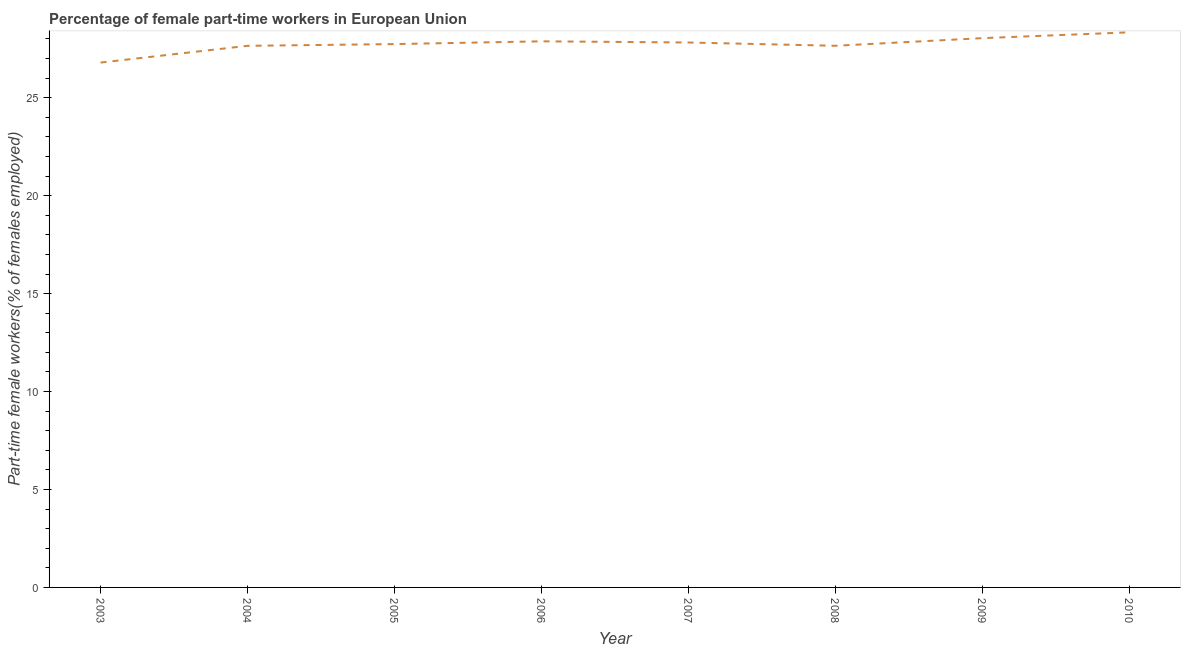What is the percentage of part-time female workers in 2006?
Make the answer very short. 27.88. Across all years, what is the maximum percentage of part-time female workers?
Give a very brief answer. 28.34. Across all years, what is the minimum percentage of part-time female workers?
Make the answer very short. 26.8. In which year was the percentage of part-time female workers minimum?
Give a very brief answer. 2003. What is the sum of the percentage of part-time female workers?
Your response must be concise. 221.92. What is the difference between the percentage of part-time female workers in 2003 and 2006?
Your response must be concise. -1.08. What is the average percentage of part-time female workers per year?
Offer a very short reply. 27.74. What is the median percentage of part-time female workers?
Offer a very short reply. 27.78. Do a majority of the years between 2010 and 2004 (inclusive) have percentage of part-time female workers greater than 24 %?
Give a very brief answer. Yes. What is the ratio of the percentage of part-time female workers in 2004 to that in 2006?
Offer a very short reply. 0.99. Is the percentage of part-time female workers in 2005 less than that in 2007?
Keep it short and to the point. Yes. What is the difference between the highest and the second highest percentage of part-time female workers?
Offer a very short reply. 0.3. What is the difference between the highest and the lowest percentage of part-time female workers?
Offer a terse response. 1.54. What is the title of the graph?
Provide a succinct answer. Percentage of female part-time workers in European Union. What is the label or title of the Y-axis?
Provide a succinct answer. Part-time female workers(% of females employed). What is the Part-time female workers(% of females employed) of 2003?
Make the answer very short. 26.8. What is the Part-time female workers(% of females employed) in 2004?
Ensure brevity in your answer.  27.65. What is the Part-time female workers(% of females employed) in 2005?
Give a very brief answer. 27.74. What is the Part-time female workers(% of females employed) in 2006?
Make the answer very short. 27.88. What is the Part-time female workers(% of females employed) of 2007?
Provide a succinct answer. 27.82. What is the Part-time female workers(% of females employed) of 2008?
Keep it short and to the point. 27.65. What is the Part-time female workers(% of females employed) in 2009?
Provide a short and direct response. 28.04. What is the Part-time female workers(% of females employed) in 2010?
Your response must be concise. 28.34. What is the difference between the Part-time female workers(% of females employed) in 2003 and 2004?
Keep it short and to the point. -0.85. What is the difference between the Part-time female workers(% of females employed) in 2003 and 2005?
Ensure brevity in your answer.  -0.94. What is the difference between the Part-time female workers(% of females employed) in 2003 and 2006?
Your answer should be very brief. -1.08. What is the difference between the Part-time female workers(% of females employed) in 2003 and 2007?
Your response must be concise. -1.02. What is the difference between the Part-time female workers(% of females employed) in 2003 and 2008?
Ensure brevity in your answer.  -0.86. What is the difference between the Part-time female workers(% of females employed) in 2003 and 2009?
Provide a short and direct response. -1.25. What is the difference between the Part-time female workers(% of females employed) in 2003 and 2010?
Offer a very short reply. -1.54. What is the difference between the Part-time female workers(% of females employed) in 2004 and 2005?
Give a very brief answer. -0.09. What is the difference between the Part-time female workers(% of females employed) in 2004 and 2006?
Offer a terse response. -0.23. What is the difference between the Part-time female workers(% of females employed) in 2004 and 2007?
Ensure brevity in your answer.  -0.17. What is the difference between the Part-time female workers(% of females employed) in 2004 and 2008?
Ensure brevity in your answer.  -0. What is the difference between the Part-time female workers(% of females employed) in 2004 and 2009?
Your answer should be very brief. -0.39. What is the difference between the Part-time female workers(% of females employed) in 2004 and 2010?
Give a very brief answer. -0.69. What is the difference between the Part-time female workers(% of females employed) in 2005 and 2006?
Give a very brief answer. -0.14. What is the difference between the Part-time female workers(% of females employed) in 2005 and 2007?
Make the answer very short. -0.08. What is the difference between the Part-time female workers(% of females employed) in 2005 and 2008?
Your answer should be compact. 0.09. What is the difference between the Part-time female workers(% of females employed) in 2005 and 2009?
Provide a short and direct response. -0.3. What is the difference between the Part-time female workers(% of females employed) in 2005 and 2010?
Ensure brevity in your answer.  -0.6. What is the difference between the Part-time female workers(% of females employed) in 2006 and 2007?
Your response must be concise. 0.06. What is the difference between the Part-time female workers(% of females employed) in 2006 and 2008?
Keep it short and to the point. 0.23. What is the difference between the Part-time female workers(% of females employed) in 2006 and 2009?
Keep it short and to the point. -0.16. What is the difference between the Part-time female workers(% of females employed) in 2006 and 2010?
Offer a very short reply. -0.46. What is the difference between the Part-time female workers(% of females employed) in 2007 and 2008?
Ensure brevity in your answer.  0.17. What is the difference between the Part-time female workers(% of females employed) in 2007 and 2009?
Ensure brevity in your answer.  -0.22. What is the difference between the Part-time female workers(% of females employed) in 2007 and 2010?
Keep it short and to the point. -0.52. What is the difference between the Part-time female workers(% of females employed) in 2008 and 2009?
Offer a terse response. -0.39. What is the difference between the Part-time female workers(% of females employed) in 2008 and 2010?
Give a very brief answer. -0.69. What is the difference between the Part-time female workers(% of females employed) in 2009 and 2010?
Offer a very short reply. -0.3. What is the ratio of the Part-time female workers(% of females employed) in 2003 to that in 2004?
Your response must be concise. 0.97. What is the ratio of the Part-time female workers(% of females employed) in 2003 to that in 2006?
Provide a succinct answer. 0.96. What is the ratio of the Part-time female workers(% of females employed) in 2003 to that in 2007?
Make the answer very short. 0.96. What is the ratio of the Part-time female workers(% of females employed) in 2003 to that in 2008?
Keep it short and to the point. 0.97. What is the ratio of the Part-time female workers(% of females employed) in 2003 to that in 2009?
Your answer should be very brief. 0.96. What is the ratio of the Part-time female workers(% of females employed) in 2003 to that in 2010?
Your response must be concise. 0.95. What is the ratio of the Part-time female workers(% of females employed) in 2004 to that in 2006?
Your answer should be very brief. 0.99. What is the ratio of the Part-time female workers(% of females employed) in 2004 to that in 2007?
Your answer should be compact. 0.99. What is the ratio of the Part-time female workers(% of females employed) in 2005 to that in 2008?
Keep it short and to the point. 1. What is the ratio of the Part-time female workers(% of females employed) in 2005 to that in 2009?
Offer a terse response. 0.99. What is the ratio of the Part-time female workers(% of females employed) in 2005 to that in 2010?
Make the answer very short. 0.98. What is the ratio of the Part-time female workers(% of females employed) in 2006 to that in 2007?
Your answer should be very brief. 1. What is the ratio of the Part-time female workers(% of females employed) in 2006 to that in 2008?
Keep it short and to the point. 1.01. What is the ratio of the Part-time female workers(% of females employed) in 2006 to that in 2010?
Give a very brief answer. 0.98. What is the ratio of the Part-time female workers(% of females employed) in 2007 to that in 2009?
Your answer should be very brief. 0.99. What is the ratio of the Part-time female workers(% of females employed) in 2007 to that in 2010?
Your answer should be very brief. 0.98. What is the ratio of the Part-time female workers(% of females employed) in 2008 to that in 2009?
Your answer should be compact. 0.99. What is the ratio of the Part-time female workers(% of females employed) in 2008 to that in 2010?
Offer a very short reply. 0.98. 